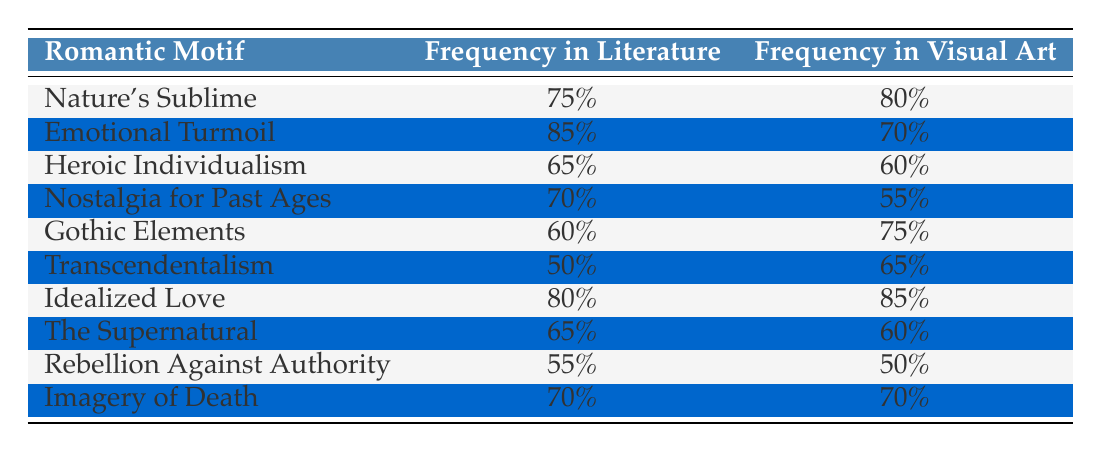What is the frequency of "Nature's Sublime" in literature? The table lists a specific entry under "Nature's Sublime" where the frequency in literature is provided as 75%.
Answer: 75% What is the percentage frequency of "Idealized Love" in visual art? Under the row for "Idealized Love," the table shows the frequency in visual art as 85%.
Answer: 85% Which Romantic motif has the highest representation in literature? By inspecting the frequency values in literature, "Emotional Turmoil" has the highest value at 85%.
Answer: Emotional Turmoil Is the frequency of "Nostalgia for Past Ages" higher in literature or visual art? The table shows that "Nostalgia for Past Ages" has a frequency of 70% in literature and 55% in visual art. Since 70% is greater than 55%, it is higher in literature.
Answer: Higher in literature What is the average frequency in literature for the motifs listed? To find the average, we sum the frequencies in literature: 75 + 85 + 65 + 70 + 60 + 50 + 80 + 65 + 55 + 70 =  735. There are 10 motifs, so we calculate the average: 735 / 10 = 73.5.
Answer: 73.5 Is "Gothic Elements" more prevalent in literature or visual art? The frequency for "Gothic Elements" is 60% in literature and 75% in visual art. Since 75% is greater than 60%, it is more prevalent in visual art.
Answer: More prevalent in visual art How much higher is the frequency of "Idealized Love" in visual arts compared to "Emotional Turmoil"? The frequency of "Idealized Love" in visual art is 85%, and "Emotional Turmoil" in visual art is 70%. The difference is 85 - 70 = 15%.
Answer: 15% Which motifs have the same frequency in both literature and visual art? By examining the table, "Imagery of Death" has a frequency of 70% in both columns.
Answer: Imagery of Death Which motif reflects the greatest difference between literature and visual art, and what is that difference? "Nostalgia for Past Ages" in literature is 70%, and in visual art, it is 55%; hence, the difference is 70 - 55 = 15%. The greatest difference is with the motif "Nostalgia for Past Ages."
Answer: Nostalgia for Past Ages, 15% difference 